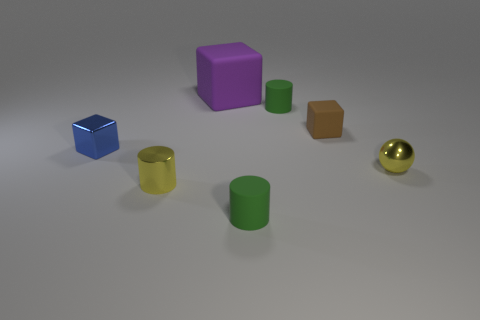What is the shape of the tiny thing that is the same color as the sphere?
Your answer should be very brief. Cylinder. What number of large yellow cylinders are there?
Make the answer very short. 0. There is a block that is on the left side of the big rubber object that is behind the brown block; what is its material?
Ensure brevity in your answer.  Metal. What is the material of the yellow object that is the same size as the yellow metallic sphere?
Your response must be concise. Metal. Is the size of the cylinder that is behind the yellow metallic ball the same as the large purple rubber cube?
Offer a very short reply. No. Do the tiny yellow object that is to the left of the large purple object and the brown thing have the same shape?
Ensure brevity in your answer.  No. How many things are tiny objects or tiny yellow metallic objects that are to the left of the big matte thing?
Your answer should be very brief. 6. Is the number of small blue things less than the number of small green matte objects?
Your response must be concise. Yes. Is the number of blue shiny things greater than the number of small cylinders?
Your answer should be compact. No. What number of other things are made of the same material as the blue block?
Provide a short and direct response. 2. 